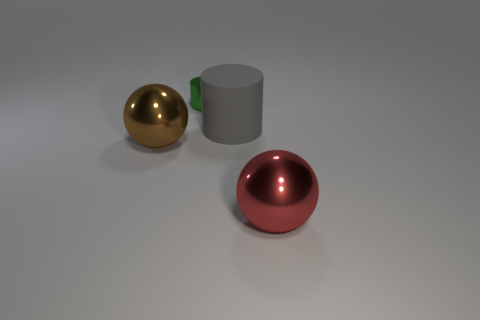Add 1 yellow matte objects. How many objects exist? 5 Subtract all gray cylinders. How many cylinders are left? 1 Add 4 big brown metal things. How many big brown metal things are left? 5 Add 1 large brown blocks. How many large brown blocks exist? 1 Subtract 1 red balls. How many objects are left? 3 Subtract 2 cylinders. How many cylinders are left? 0 Subtract all gray balls. Subtract all green blocks. How many balls are left? 2 Subtract all cyan cylinders. How many green balls are left? 0 Subtract all red metal things. Subtract all red shiny cylinders. How many objects are left? 3 